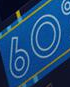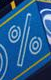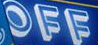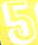What words are shown in these images in order, separated by a semicolon? 60; %; OFF; 5 